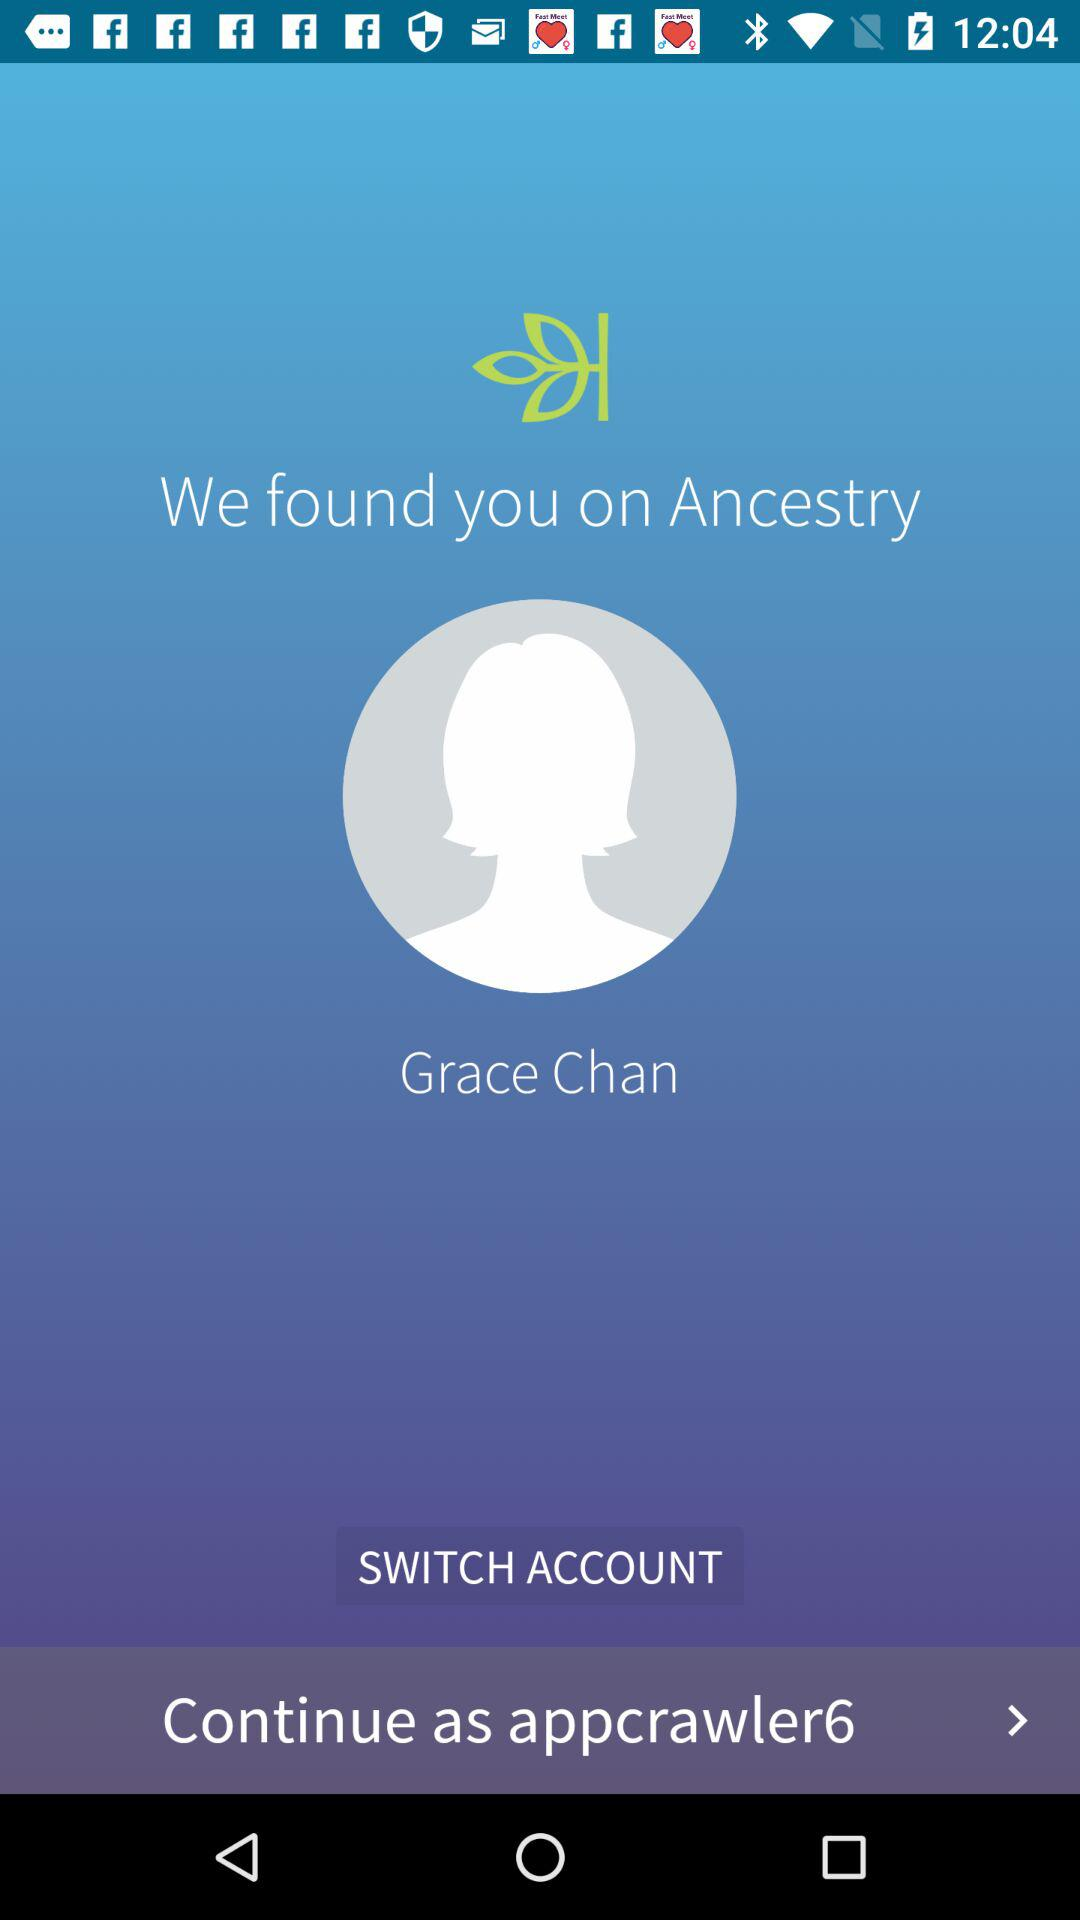What's the username that can be used to continue working on the application? The username that can be used to continue working on the application is "appcrawler6". 